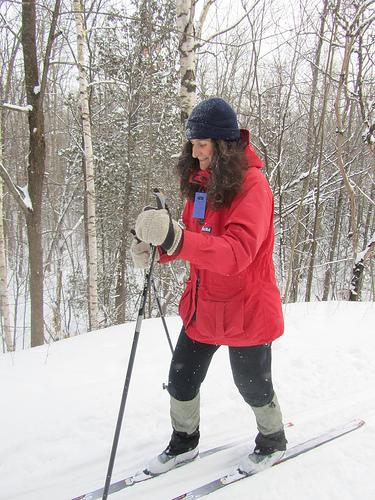Infer the type of skiing the woman is performing based on the image. The woman appears to be cross country skiing, given the presence of ski poles and the ski tracks in the snow. Analyze the context of the image, and determine what the woman's possible purpose could be while skiing. The woman is likely engaging in recreational skiing for leisure, exercise, or enjoyment, as she is dressed in proper ski attire and equipment and skiing down a snow-covered slope surrounded by trees. Provide a detailed description of the woman's attire in the image. The woman is wearing a black ski cap dusted with snow, red winter jacket, black ski pants, and white gloves. She also has ski boots attached to the skis and is holding ski poles. List all the items related to skiing that the woman is using. Skis, ski poles, ski boots, ski cap, ski jacket, ski pants, and ski gloves. Describe the specific colors of the woman's attire and equipment in the image. The woman is wearing a black ski cap, a red winter jacket, black ski pants, and white gloves. She is also equipped with skis and ski poles. Is there a lot of snow in the image? If so, where is it located primarily? Yes, there is lots of snow on the slopes and plenty of snow on the ground. Many trees in the image are dusted with snow as well. Analyze the sentiment in the image based on the setting and the woman's activity. The sentiment in the image is energetic and joyful as the woman is participating in a fun and exciting outdoor winter sport, skiing down a snow-covered slope. What type of footwear is the woman wearing while skiing? The woman is wearing ski boots attached to her skis for skiing. Identify any notable features about the trees that are present in the image. Many of the trees in the image are bare and dusted with snow, suggesting a cold and wintery environment. What can you say about the location where the woman is skiing? The woman is skiing down a hill surrounded by many bare trees dusted with snow, indicating a snowy and potentially mountainous terrain. 